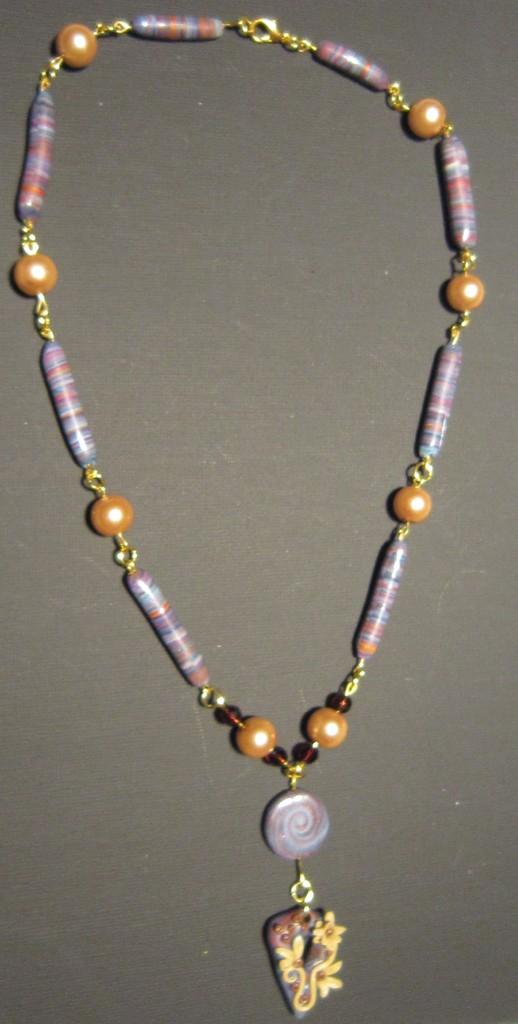What is the main subject of the image? The main subject of the image is a chain with a pendant. Can you describe the pendant's appearance? The provided facts do not mention the pendant's appearance. Where is the chain and pendant located in the image? The chain and pendant are present on a surface in the image. How many visitors are present in the image? There is no mention of visitors in the image. What type of shoes can be seen on the visitors in the image? There is no mention of visitors or shoes in the image. What color is the curtain behind the pendant in the image? The provided facts do not mention a curtain in the image. 